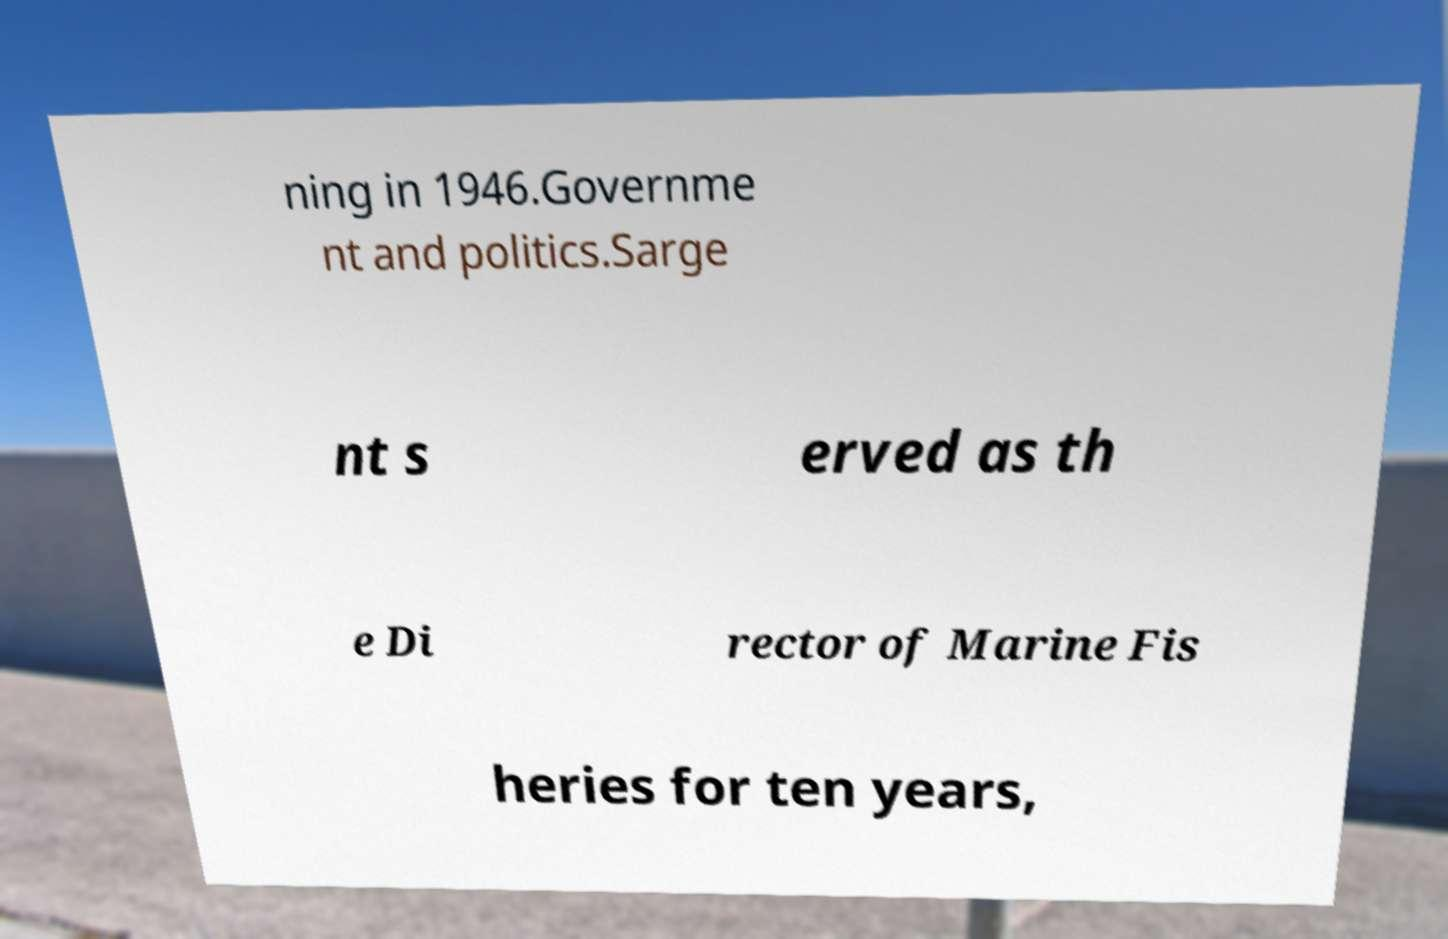There's text embedded in this image that I need extracted. Can you transcribe it verbatim? ning in 1946.Governme nt and politics.Sarge nt s erved as th e Di rector of Marine Fis heries for ten years, 